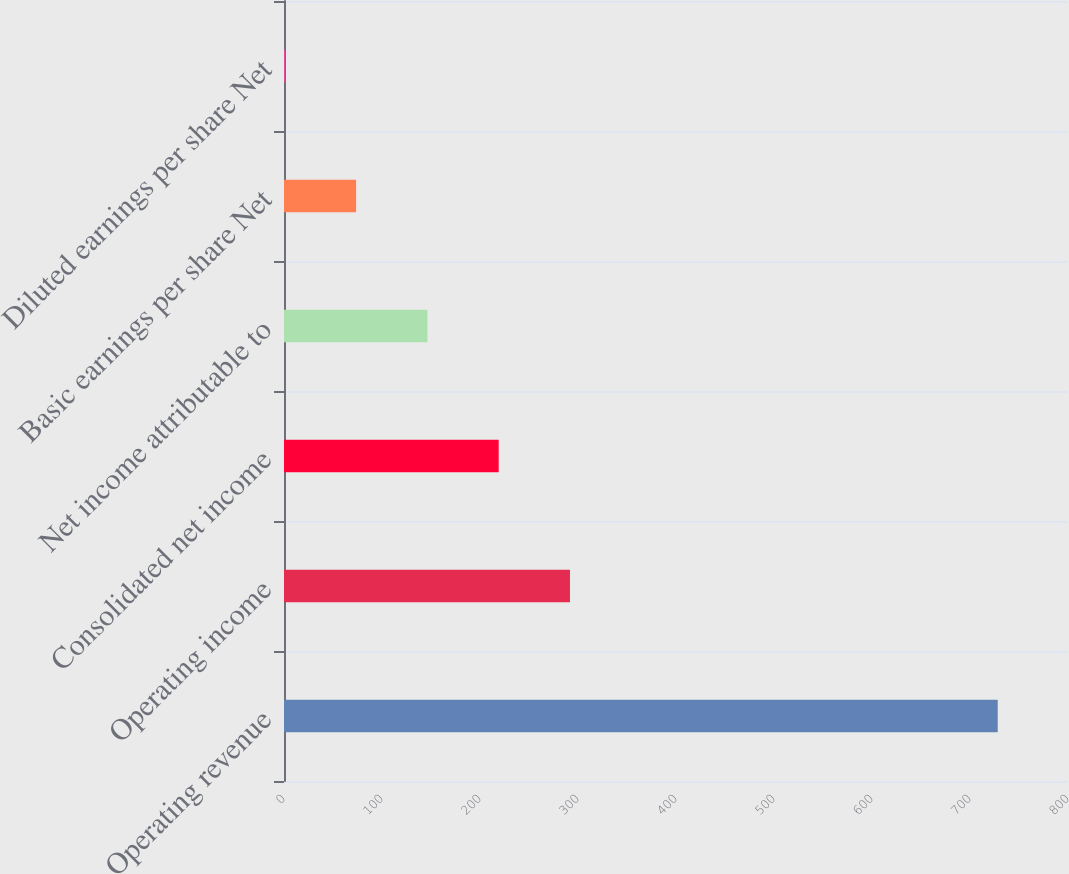Convert chart. <chart><loc_0><loc_0><loc_500><loc_500><bar_chart><fcel>Operating revenue<fcel>Operating income<fcel>Consolidated net income<fcel>Net income attributable to<fcel>Basic earnings per share Net<fcel>Diluted earnings per share Net<nl><fcel>728.3<fcel>291.81<fcel>219.07<fcel>146.33<fcel>73.59<fcel>0.85<nl></chart> 